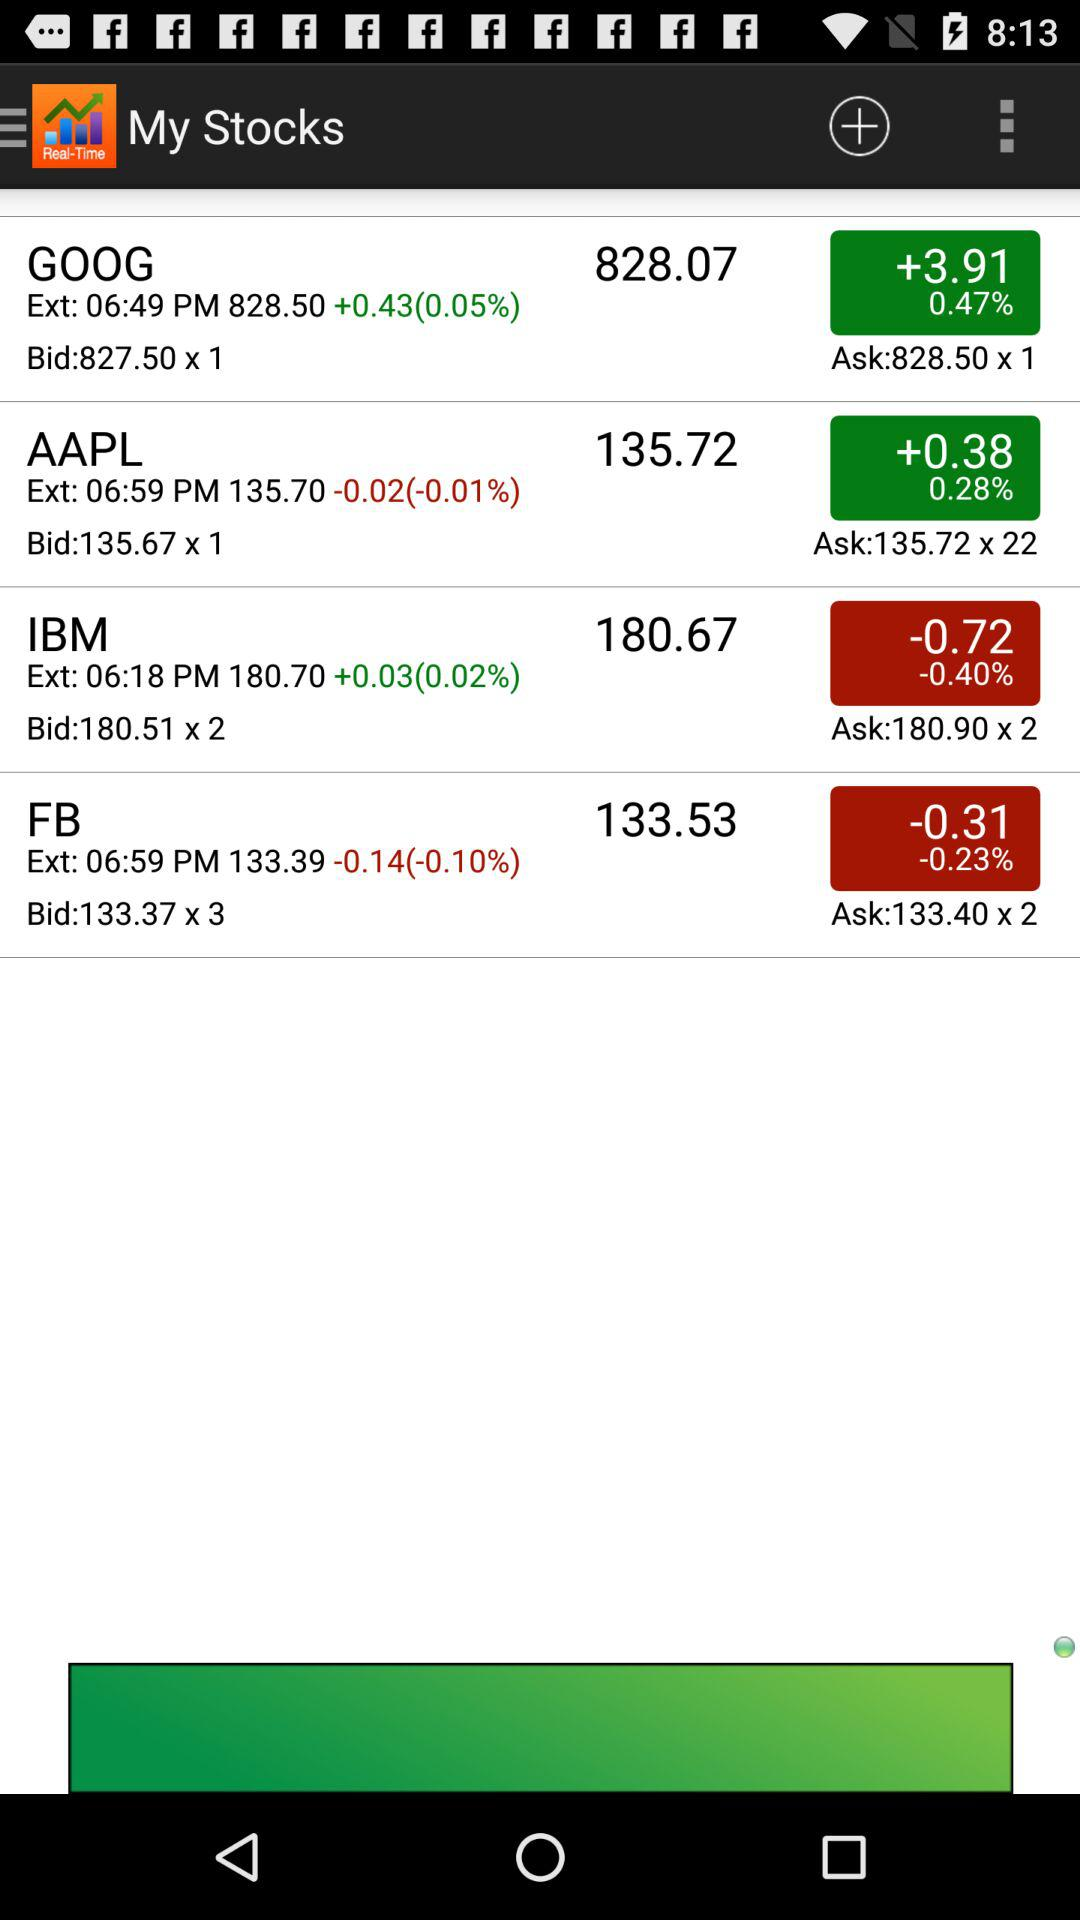What is the bid for FB? The bid for FB is 133.37x3. 